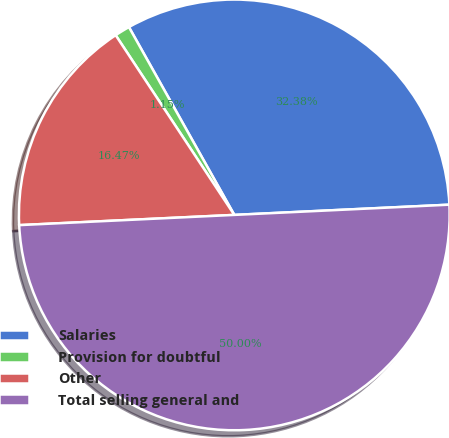Convert chart. <chart><loc_0><loc_0><loc_500><loc_500><pie_chart><fcel>Salaries<fcel>Provision for doubtful<fcel>Other<fcel>Total selling general and<nl><fcel>32.38%<fcel>1.15%<fcel>16.47%<fcel>50.0%<nl></chart> 